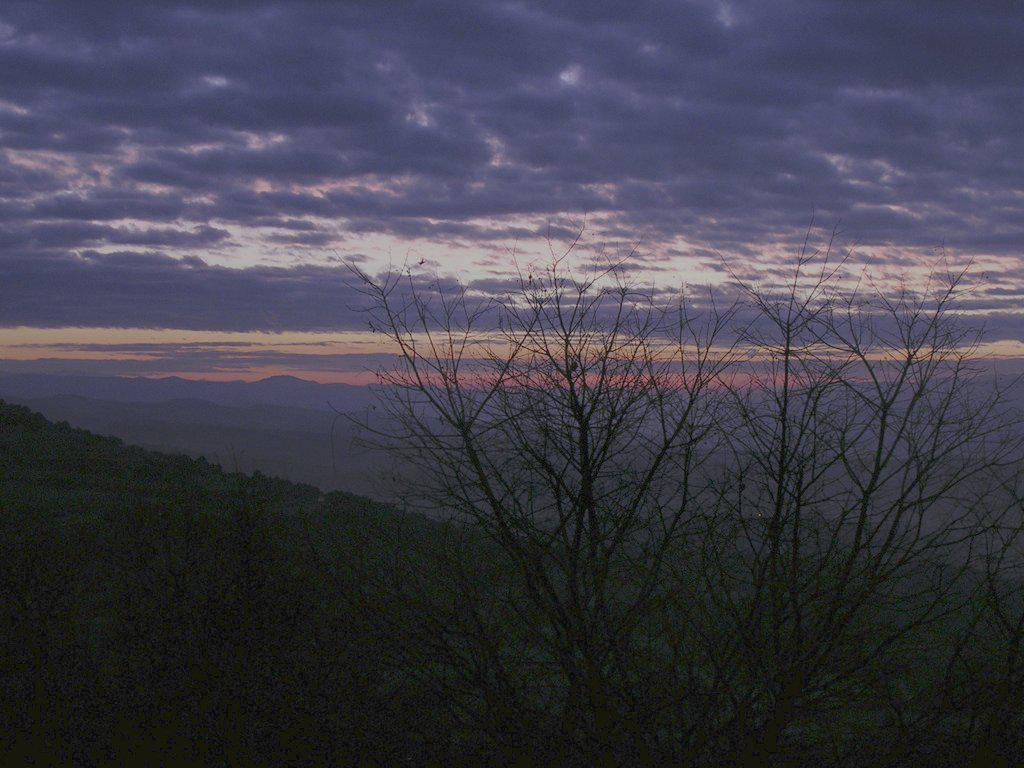What type of vegetation can be seen in the image? There are trees in the image. What geographical features are present in the image? There are hills in the image. What can be seen in the sky in the image? There are clouds visible in the sky in the image. Where is the cable attached to in the image? There is no cable present in the image. What type of patch is visible on the trees in the image? There are no patches visible on the trees in the image. 